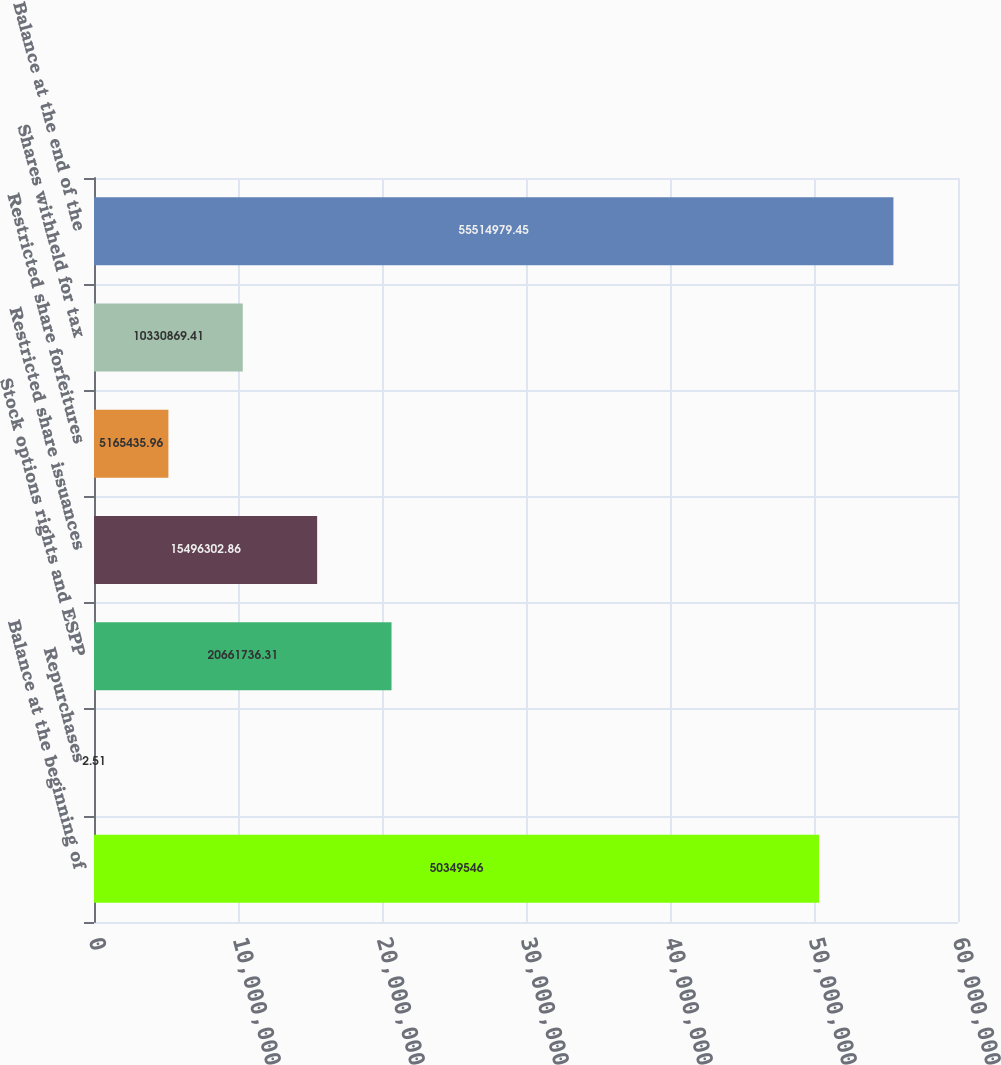Convert chart to OTSL. <chart><loc_0><loc_0><loc_500><loc_500><bar_chart><fcel>Balance at the beginning of<fcel>Repurchases<fcel>Stock options rights and ESPP<fcel>Restricted share issuances<fcel>Restricted share forfeitures<fcel>Shares withheld for tax<fcel>Balance at the end of the<nl><fcel>5.03495e+07<fcel>2.51<fcel>2.06617e+07<fcel>1.54963e+07<fcel>5.16544e+06<fcel>1.03309e+07<fcel>5.5515e+07<nl></chart> 